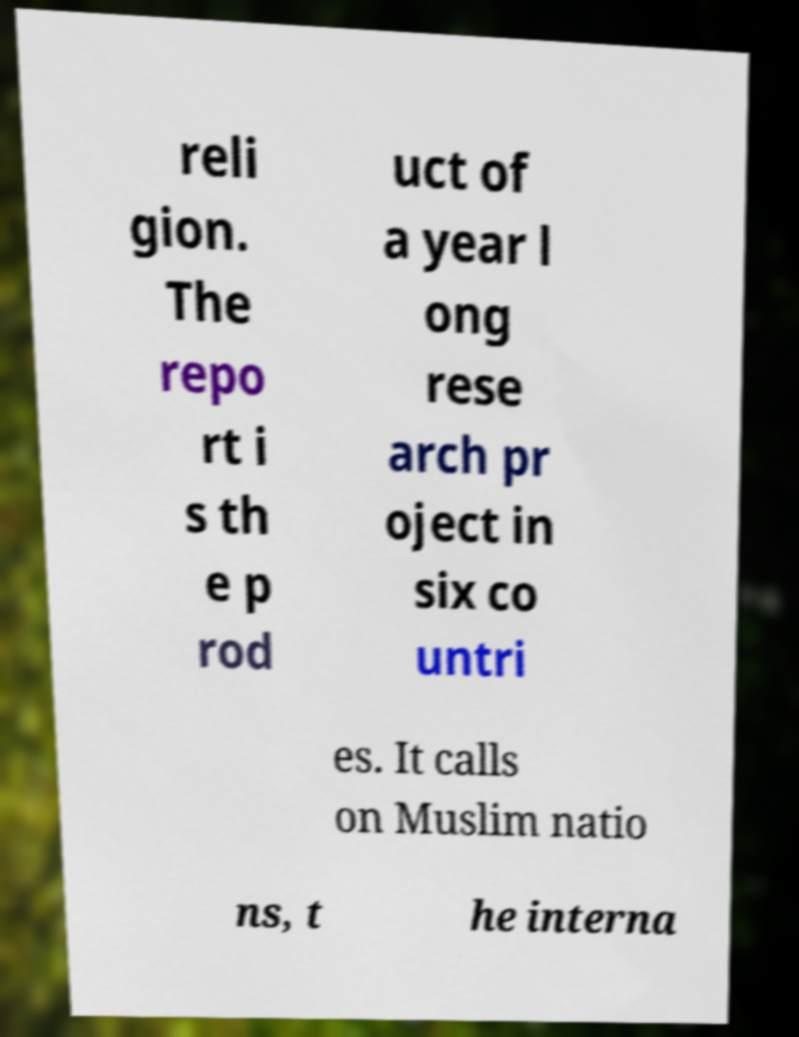Could you extract and type out the text from this image? reli gion. The repo rt i s th e p rod uct of a year l ong rese arch pr oject in six co untri es. It calls on Muslim natio ns, t he interna 